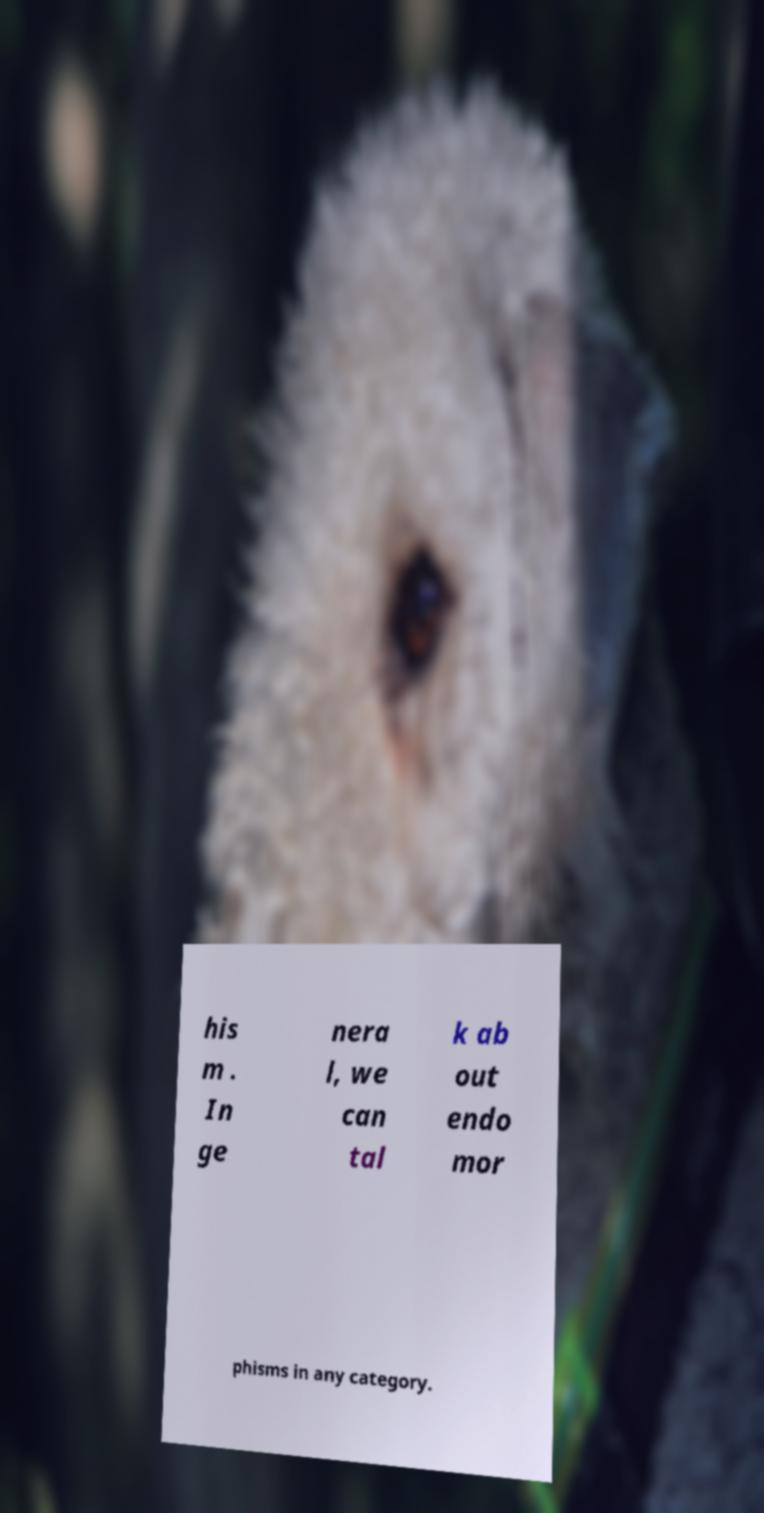There's text embedded in this image that I need extracted. Can you transcribe it verbatim? his m . In ge nera l, we can tal k ab out endo mor phisms in any category. 